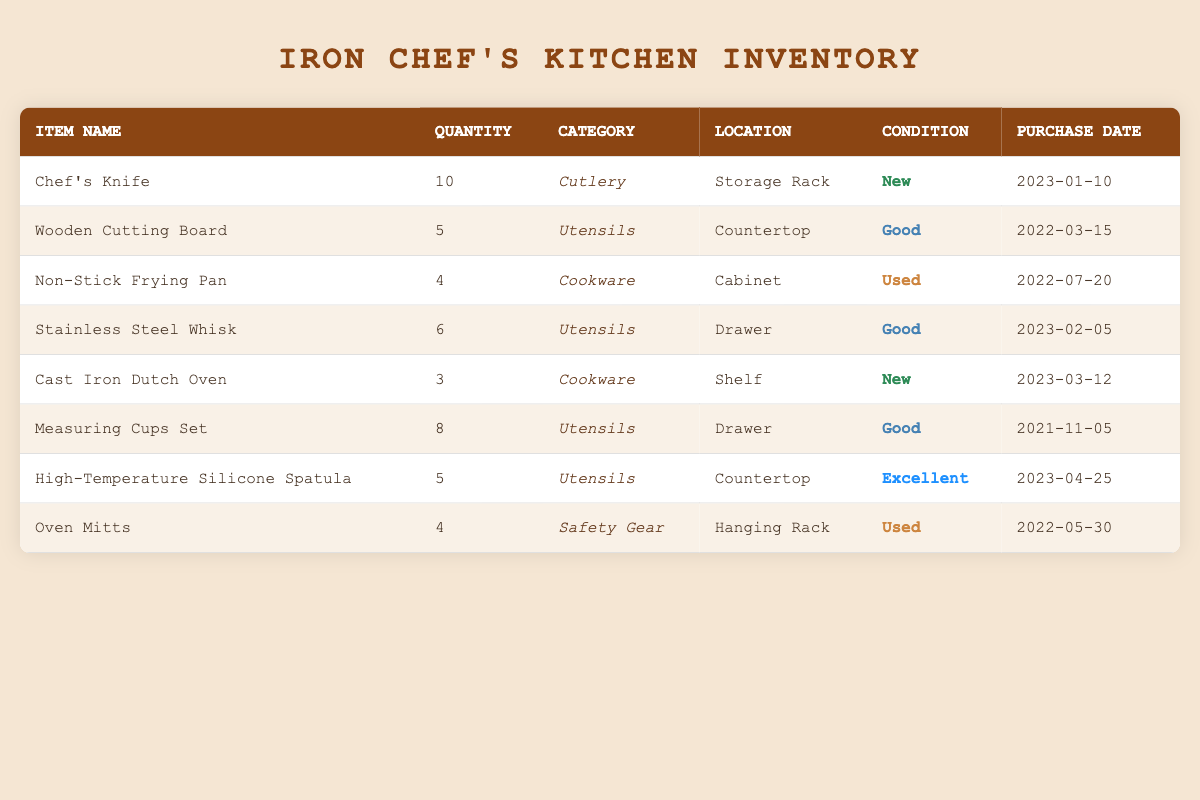What is the total quantity of cooking utensils? To find the total quantity of cooking utensils, we need to look at the rows where the category is "Utensils." The quantities are 5 (Wooden Cutting Board), 6 (Stainless Steel Whisk), 8 (Measuring Cups Set), and 5 (High-Temperature Silicone Spatula). Adding those up gives us 5 + 6 + 8 + 5 = 24.
Answer: 24 How many items in the inventory are classified as "New"? We can identify items with the condition "New" by checking each row. There are two items listed as new: the Chef's Knife (10) and the Cast Iron Dutch Oven (3). Therefore, there are 2 items in total with that condition.
Answer: 2 Is there any cookware item located in the Cabinet? By checking the table, the Non-Stick Frying Pan is the only cookware item listed, and its location is noted as "Cabinet." Therefore, the answer to this question is yes.
Answer: Yes What is the average quantity of utensils in the kitchen inventory? The total quantities for utensils include 5 (Wooden Cutting Board), 6 (Stainless Steel Whisk), 8 (Measuring Cups Set), and 5 (High-Temperature Silicone Spatula), making the sum 24. There are 4 utensils in total, so the average is 24 divided by 4, which equals 6.
Answer: 6 How many items have a condition of "Used"? Looking at the table, the items with a condition of "Used" are the Non-Stick Frying Pan and Oven Mitts. There are two items with that condition in total.
Answer: 2 Which utensil has the highest quantity? Reviewing the quantities for utensils, we see that the Measuring Cups Set has the highest quantity at 8, while other utensils have lower quantities. Therefore, the Measuring Cups Set is the answer.
Answer: Measuring Cups Set Are there any items purchased in 2023? The items purchased in 2023 are the Chef's Knife (January 10), Stainless Steel Whisk (February 5), Cast Iron Dutch Oven (March 12), and High-Temperature Silicone Spatula (April 25). Therefore, there are indeed items purchased in 2023.
Answer: Yes What is the total quantity of items located on the countertop? The items located on the countertop are the Wooden Cutting Board (quantity of 5) and the High-Temperature Silicone Spatula (quantity of 5). Adding these gives us a total of 5 + 5 = 10.
Answer: 10 How many utensils are in "Excellent" condition? Checking the condition of each item, only the High-Temperature Silicone Spatula is classified as "Excellent." Therefore, there is just one utensil in that condition.
Answer: 1 